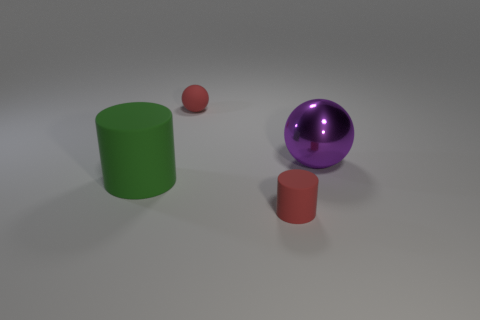Does the shiny sphere have the same color as the big matte cylinder?
Offer a very short reply. No. There is a object in front of the cylinder that is to the left of the red matte cylinder; what size is it?
Your answer should be compact. Small. There is a tiny ball; is it the same color as the large thing to the left of the purple metallic sphere?
Offer a very short reply. No. There is a cylinder that is the same size as the purple shiny ball; what is its material?
Offer a terse response. Rubber. Are there fewer red objects that are behind the tiny matte sphere than matte things in front of the tiny cylinder?
Keep it short and to the point. No. What shape is the tiny matte thing that is to the left of the matte cylinder to the right of the red rubber ball?
Your answer should be compact. Sphere. Are there any tiny red cylinders?
Offer a terse response. Yes. There is a ball to the left of the large purple sphere; what is its color?
Provide a short and direct response. Red. What is the material of the object that is the same color as the small ball?
Offer a very short reply. Rubber. There is a green rubber object; are there any big shiny objects on the left side of it?
Your response must be concise. No. 